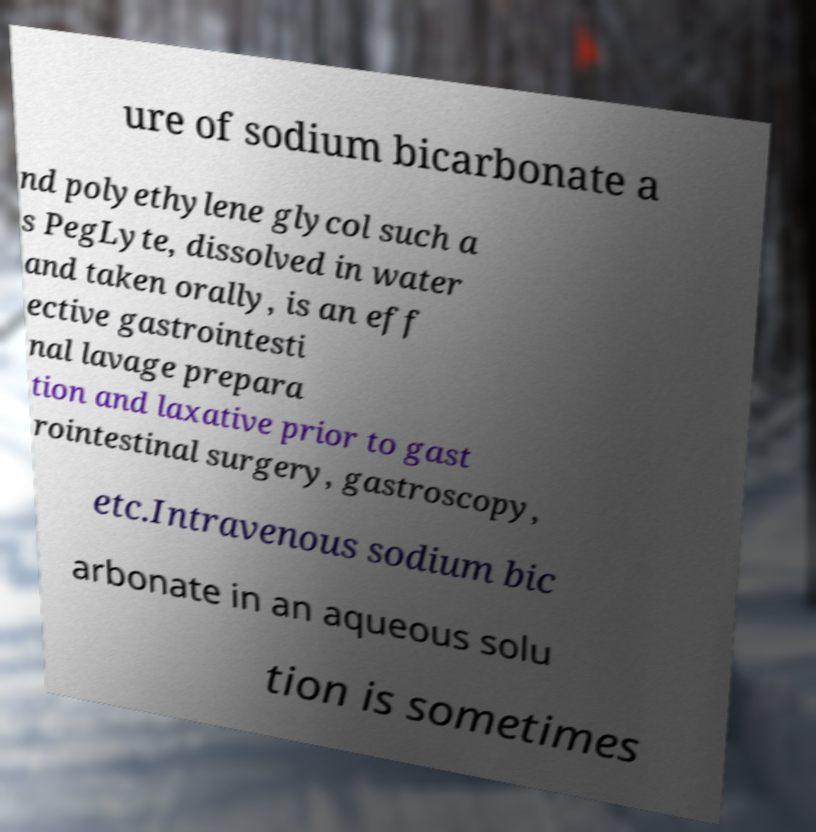What messages or text are displayed in this image? I need them in a readable, typed format. ure of sodium bicarbonate a nd polyethylene glycol such a s PegLyte, dissolved in water and taken orally, is an eff ective gastrointesti nal lavage prepara tion and laxative prior to gast rointestinal surgery, gastroscopy, etc.Intravenous sodium bic arbonate in an aqueous solu tion is sometimes 